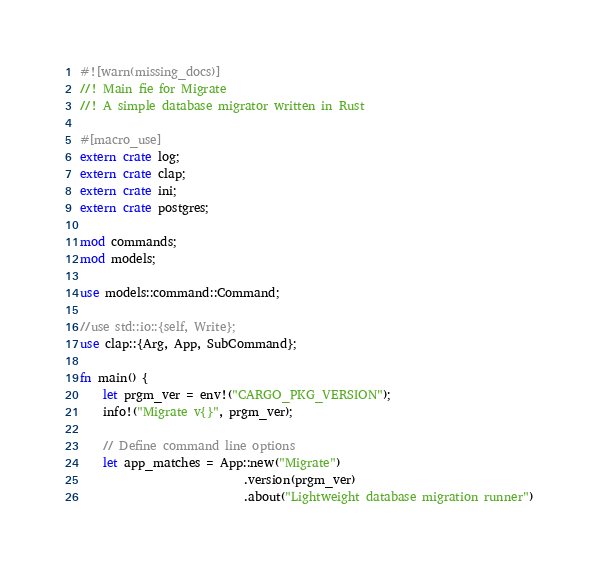<code> <loc_0><loc_0><loc_500><loc_500><_Rust_>#![warn(missing_docs)]
//! Main fie for Migrate
//! A simple database migrator written in Rust

#[macro_use]
extern crate log;
extern crate clap;
extern crate ini;
extern crate postgres;

mod commands;
mod models;

use models::command::Command;

//use std::io::{self, Write};
use clap::{Arg, App, SubCommand};

fn main() {
    let prgm_ver = env!("CARGO_PKG_VERSION");
    info!("Migrate v{}", prgm_ver);

    // Define command line options
    let app_matches = App::new("Migrate")
                            .version(prgm_ver)
                            .about("Lightweight database migration runner")</code> 